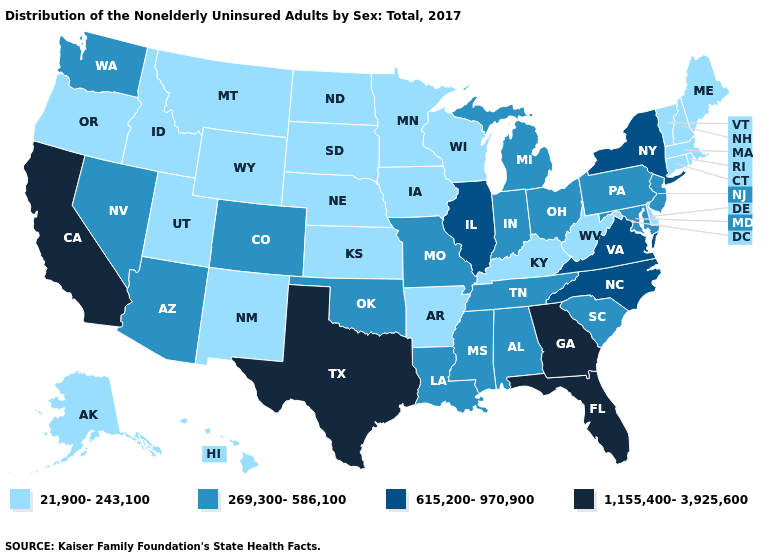Which states have the lowest value in the USA?
Answer briefly. Alaska, Arkansas, Connecticut, Delaware, Hawaii, Idaho, Iowa, Kansas, Kentucky, Maine, Massachusetts, Minnesota, Montana, Nebraska, New Hampshire, New Mexico, North Dakota, Oregon, Rhode Island, South Dakota, Utah, Vermont, West Virginia, Wisconsin, Wyoming. Does Hawaii have the lowest value in the West?
Answer briefly. Yes. What is the highest value in states that border Illinois?
Give a very brief answer. 269,300-586,100. Name the states that have a value in the range 269,300-586,100?
Be succinct. Alabama, Arizona, Colorado, Indiana, Louisiana, Maryland, Michigan, Mississippi, Missouri, Nevada, New Jersey, Ohio, Oklahoma, Pennsylvania, South Carolina, Tennessee, Washington. Does the map have missing data?
Give a very brief answer. No. Does Kansas have the highest value in the MidWest?
Answer briefly. No. Does Washington have a higher value than Nebraska?
Give a very brief answer. Yes. How many symbols are there in the legend?
Quick response, please. 4. Among the states that border Kansas , does Missouri have the lowest value?
Write a very short answer. No. Name the states that have a value in the range 1,155,400-3,925,600?
Concise answer only. California, Florida, Georgia, Texas. What is the value of Michigan?
Write a very short answer. 269,300-586,100. Name the states that have a value in the range 1,155,400-3,925,600?
Concise answer only. California, Florida, Georgia, Texas. Name the states that have a value in the range 21,900-243,100?
Concise answer only. Alaska, Arkansas, Connecticut, Delaware, Hawaii, Idaho, Iowa, Kansas, Kentucky, Maine, Massachusetts, Minnesota, Montana, Nebraska, New Hampshire, New Mexico, North Dakota, Oregon, Rhode Island, South Dakota, Utah, Vermont, West Virginia, Wisconsin, Wyoming. Does Mississippi have the lowest value in the South?
Short answer required. No. 